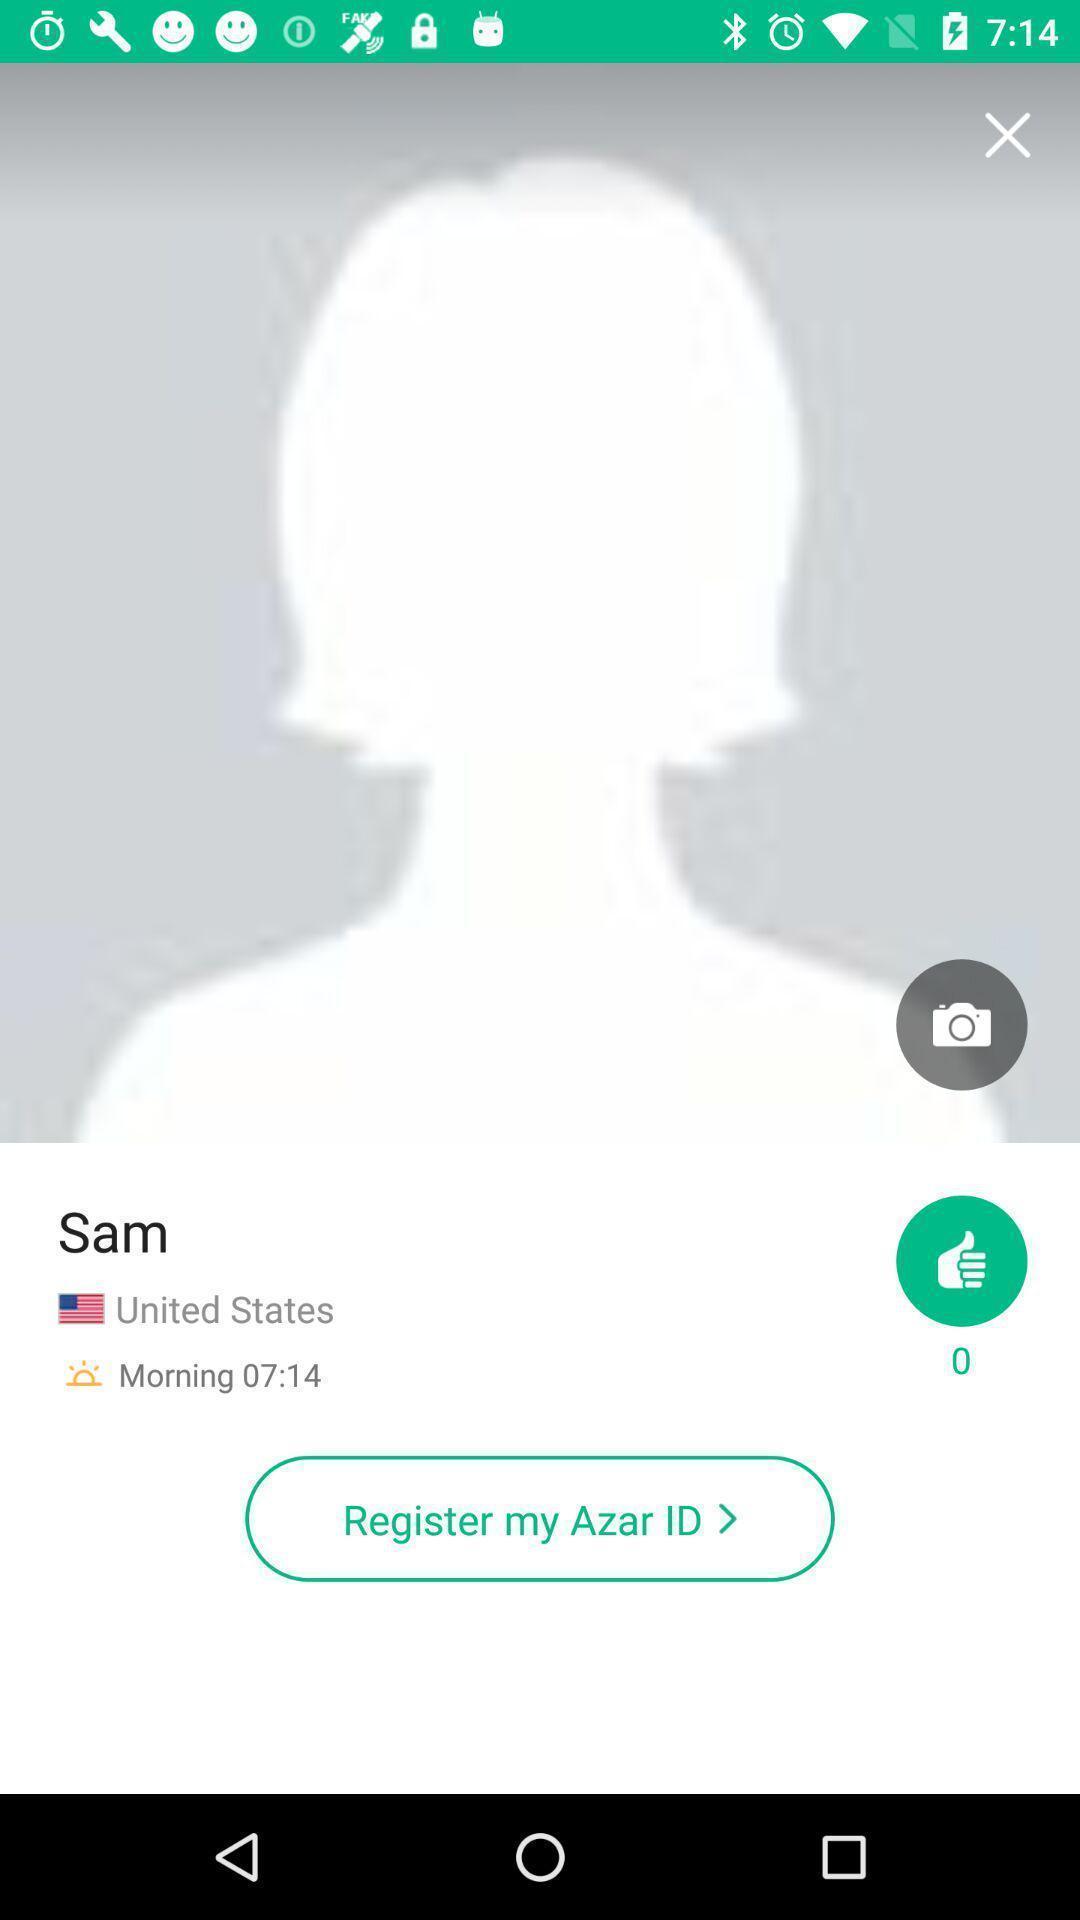Describe this image in words. Window displaying profile for registration. 